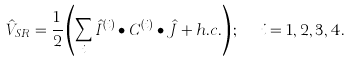Convert formula to latex. <formula><loc_0><loc_0><loc_500><loc_500>\hat { V } _ { S R } = \frac { 1 } { 2 } \left ( \sum _ { i } \hat { I } ^ { ( i ) } \bullet { C } ^ { ( i ) } \bullet \hat { J } + h . c . \right ) ; \ \ i = 1 , 2 , 3 , 4 .</formula> 